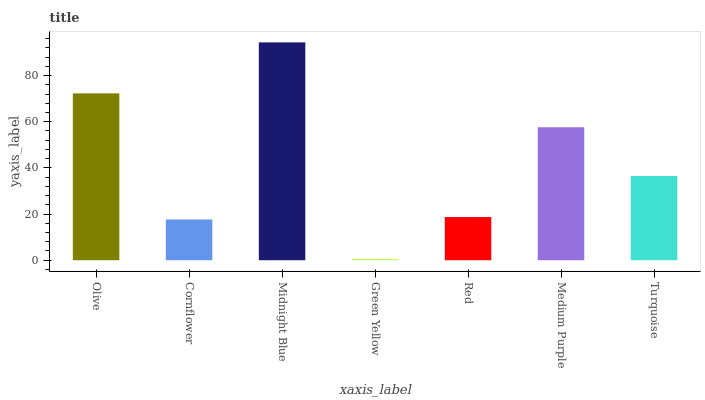Is Green Yellow the minimum?
Answer yes or no. Yes. Is Midnight Blue the maximum?
Answer yes or no. Yes. Is Cornflower the minimum?
Answer yes or no. No. Is Cornflower the maximum?
Answer yes or no. No. Is Olive greater than Cornflower?
Answer yes or no. Yes. Is Cornflower less than Olive?
Answer yes or no. Yes. Is Cornflower greater than Olive?
Answer yes or no. No. Is Olive less than Cornflower?
Answer yes or no. No. Is Turquoise the high median?
Answer yes or no. Yes. Is Turquoise the low median?
Answer yes or no. Yes. Is Olive the high median?
Answer yes or no. No. Is Olive the low median?
Answer yes or no. No. 